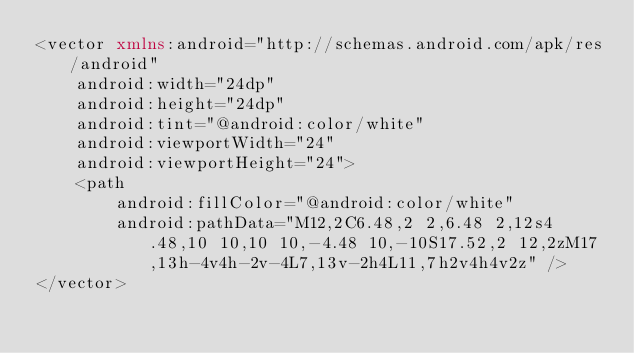Convert code to text. <code><loc_0><loc_0><loc_500><loc_500><_XML_><vector xmlns:android="http://schemas.android.com/apk/res/android"
    android:width="24dp"
    android:height="24dp"
    android:tint="@android:color/white"
    android:viewportWidth="24"
    android:viewportHeight="24">
    <path
        android:fillColor="@android:color/white"
        android:pathData="M12,2C6.48,2 2,6.48 2,12s4.48,10 10,10 10,-4.48 10,-10S17.52,2 12,2zM17,13h-4v4h-2v-4L7,13v-2h4L11,7h2v4h4v2z" />
</vector>
</code> 